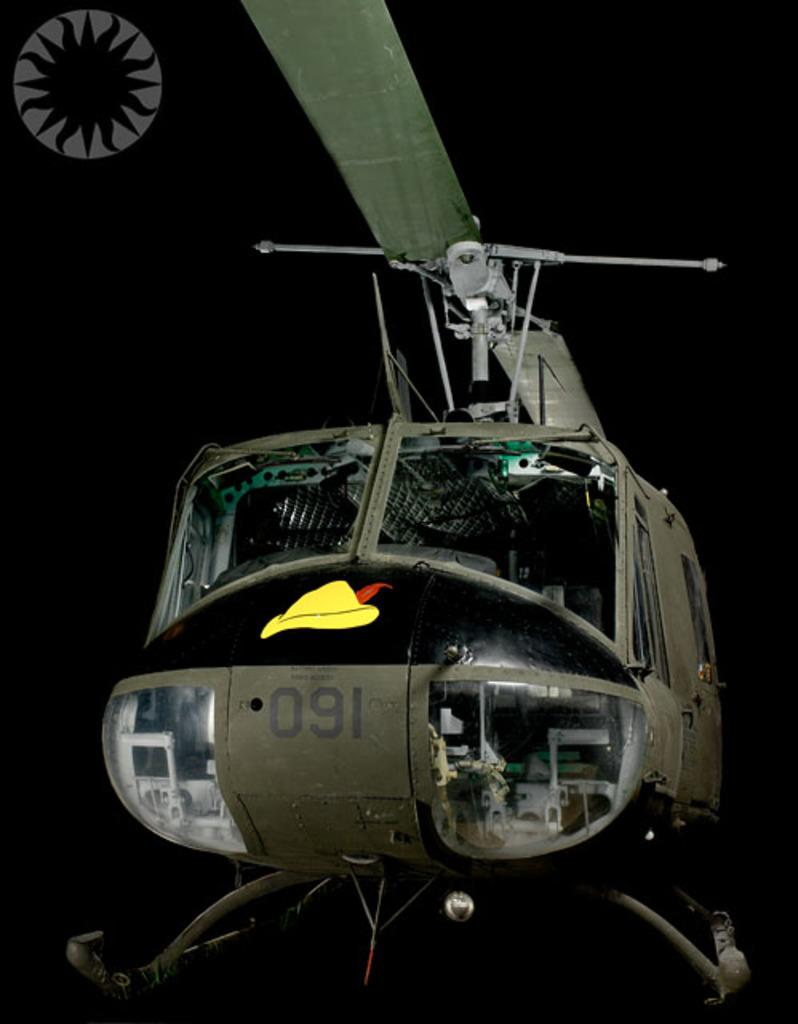<image>
Give a short and clear explanation of the subsequent image. a green 091 helicopter is against a black background 